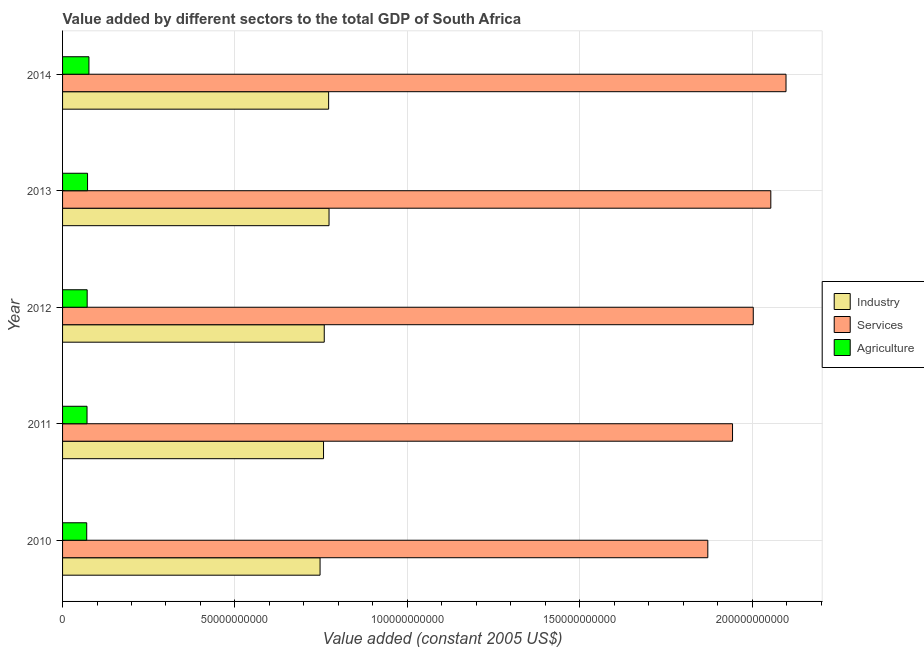How many different coloured bars are there?
Ensure brevity in your answer.  3. Are the number of bars per tick equal to the number of legend labels?
Ensure brevity in your answer.  Yes. Are the number of bars on each tick of the Y-axis equal?
Your answer should be compact. Yes. How many bars are there on the 5th tick from the top?
Your answer should be very brief. 3. How many bars are there on the 2nd tick from the bottom?
Make the answer very short. 3. In how many cases, is the number of bars for a given year not equal to the number of legend labels?
Offer a very short reply. 0. What is the value added by agricultural sector in 2013?
Provide a succinct answer. 7.25e+09. Across all years, what is the maximum value added by industrial sector?
Provide a succinct answer. 7.73e+1. Across all years, what is the minimum value added by agricultural sector?
Offer a very short reply. 7.00e+09. In which year was the value added by agricultural sector minimum?
Your response must be concise. 2010. What is the total value added by agricultural sector in the graph?
Your response must be concise. 3.61e+1. What is the difference between the value added by services in 2012 and that in 2014?
Ensure brevity in your answer.  -9.50e+09. What is the difference between the value added by industrial sector in 2010 and the value added by agricultural sector in 2013?
Your answer should be compact. 6.74e+1. What is the average value added by industrial sector per year?
Keep it short and to the point. 7.62e+1. In the year 2012, what is the difference between the value added by services and value added by agricultural sector?
Keep it short and to the point. 1.93e+11. In how many years, is the value added by industrial sector greater than 210000000000 US$?
Your response must be concise. 0. What is the ratio of the value added by agricultural sector in 2011 to that in 2012?
Offer a terse response. 0.99. Is the value added by industrial sector in 2011 less than that in 2013?
Give a very brief answer. Yes. Is the difference between the value added by agricultural sector in 2011 and 2013 greater than the difference between the value added by industrial sector in 2011 and 2013?
Offer a very short reply. Yes. What is the difference between the highest and the second highest value added by industrial sector?
Provide a succinct answer. 1.20e+08. What is the difference between the highest and the lowest value added by agricultural sector?
Offer a terse response. 6.46e+08. What does the 3rd bar from the top in 2011 represents?
Ensure brevity in your answer.  Industry. What does the 2nd bar from the bottom in 2014 represents?
Provide a short and direct response. Services. Is it the case that in every year, the sum of the value added by industrial sector and value added by services is greater than the value added by agricultural sector?
Keep it short and to the point. Yes. How many bars are there?
Your answer should be very brief. 15. Are all the bars in the graph horizontal?
Offer a terse response. Yes. How many years are there in the graph?
Provide a short and direct response. 5. Are the values on the major ticks of X-axis written in scientific E-notation?
Offer a very short reply. No. Does the graph contain any zero values?
Keep it short and to the point. No. Does the graph contain grids?
Provide a short and direct response. Yes. Where does the legend appear in the graph?
Provide a succinct answer. Center right. How many legend labels are there?
Make the answer very short. 3. What is the title of the graph?
Offer a very short reply. Value added by different sectors to the total GDP of South Africa. What is the label or title of the X-axis?
Give a very brief answer. Value added (constant 2005 US$). What is the Value added (constant 2005 US$) of Industry in 2010?
Your answer should be compact. 7.47e+1. What is the Value added (constant 2005 US$) in Services in 2010?
Your response must be concise. 1.87e+11. What is the Value added (constant 2005 US$) of Agriculture in 2010?
Offer a very short reply. 7.00e+09. What is the Value added (constant 2005 US$) in Industry in 2011?
Your response must be concise. 7.57e+1. What is the Value added (constant 2005 US$) in Services in 2011?
Your answer should be very brief. 1.94e+11. What is the Value added (constant 2005 US$) in Agriculture in 2011?
Your answer should be compact. 7.10e+09. What is the Value added (constant 2005 US$) of Industry in 2012?
Ensure brevity in your answer.  7.59e+1. What is the Value added (constant 2005 US$) of Services in 2012?
Make the answer very short. 2.00e+11. What is the Value added (constant 2005 US$) of Agriculture in 2012?
Your answer should be compact. 7.14e+09. What is the Value added (constant 2005 US$) of Industry in 2013?
Offer a very short reply. 7.73e+1. What is the Value added (constant 2005 US$) of Services in 2013?
Offer a very short reply. 2.05e+11. What is the Value added (constant 2005 US$) in Agriculture in 2013?
Make the answer very short. 7.25e+09. What is the Value added (constant 2005 US$) of Industry in 2014?
Offer a very short reply. 7.72e+1. What is the Value added (constant 2005 US$) of Services in 2014?
Give a very brief answer. 2.10e+11. What is the Value added (constant 2005 US$) in Agriculture in 2014?
Give a very brief answer. 7.65e+09. Across all years, what is the maximum Value added (constant 2005 US$) in Industry?
Offer a very short reply. 7.73e+1. Across all years, what is the maximum Value added (constant 2005 US$) of Services?
Your answer should be very brief. 2.10e+11. Across all years, what is the maximum Value added (constant 2005 US$) of Agriculture?
Offer a very short reply. 7.65e+09. Across all years, what is the minimum Value added (constant 2005 US$) of Industry?
Provide a succinct answer. 7.47e+1. Across all years, what is the minimum Value added (constant 2005 US$) in Services?
Offer a terse response. 1.87e+11. Across all years, what is the minimum Value added (constant 2005 US$) of Agriculture?
Give a very brief answer. 7.00e+09. What is the total Value added (constant 2005 US$) of Industry in the graph?
Ensure brevity in your answer.  3.81e+11. What is the total Value added (constant 2005 US$) in Services in the graph?
Make the answer very short. 9.97e+11. What is the total Value added (constant 2005 US$) in Agriculture in the graph?
Ensure brevity in your answer.  3.61e+1. What is the difference between the Value added (constant 2005 US$) of Industry in 2010 and that in 2011?
Offer a very short reply. -1.01e+09. What is the difference between the Value added (constant 2005 US$) of Services in 2010 and that in 2011?
Offer a terse response. -7.17e+09. What is the difference between the Value added (constant 2005 US$) of Agriculture in 2010 and that in 2011?
Give a very brief answer. -9.17e+07. What is the difference between the Value added (constant 2005 US$) of Industry in 2010 and that in 2012?
Your answer should be compact. -1.22e+09. What is the difference between the Value added (constant 2005 US$) of Services in 2010 and that in 2012?
Your response must be concise. -1.32e+1. What is the difference between the Value added (constant 2005 US$) in Agriculture in 2010 and that in 2012?
Keep it short and to the point. -1.34e+08. What is the difference between the Value added (constant 2005 US$) of Industry in 2010 and that in 2013?
Keep it short and to the point. -2.60e+09. What is the difference between the Value added (constant 2005 US$) of Services in 2010 and that in 2013?
Give a very brief answer. -1.83e+1. What is the difference between the Value added (constant 2005 US$) in Agriculture in 2010 and that in 2013?
Keep it short and to the point. -2.43e+08. What is the difference between the Value added (constant 2005 US$) in Industry in 2010 and that in 2014?
Provide a short and direct response. -2.48e+09. What is the difference between the Value added (constant 2005 US$) in Services in 2010 and that in 2014?
Offer a terse response. -2.27e+1. What is the difference between the Value added (constant 2005 US$) in Agriculture in 2010 and that in 2014?
Provide a short and direct response. -6.46e+08. What is the difference between the Value added (constant 2005 US$) in Industry in 2011 and that in 2012?
Give a very brief answer. -2.09e+08. What is the difference between the Value added (constant 2005 US$) of Services in 2011 and that in 2012?
Provide a short and direct response. -6.01e+09. What is the difference between the Value added (constant 2005 US$) in Agriculture in 2011 and that in 2012?
Offer a very short reply. -4.24e+07. What is the difference between the Value added (constant 2005 US$) of Industry in 2011 and that in 2013?
Provide a short and direct response. -1.60e+09. What is the difference between the Value added (constant 2005 US$) in Services in 2011 and that in 2013?
Provide a succinct answer. -1.11e+1. What is the difference between the Value added (constant 2005 US$) of Agriculture in 2011 and that in 2013?
Keep it short and to the point. -1.51e+08. What is the difference between the Value added (constant 2005 US$) of Industry in 2011 and that in 2014?
Keep it short and to the point. -1.48e+09. What is the difference between the Value added (constant 2005 US$) in Services in 2011 and that in 2014?
Offer a terse response. -1.55e+1. What is the difference between the Value added (constant 2005 US$) in Agriculture in 2011 and that in 2014?
Ensure brevity in your answer.  -5.55e+08. What is the difference between the Value added (constant 2005 US$) of Industry in 2012 and that in 2013?
Give a very brief answer. -1.39e+09. What is the difference between the Value added (constant 2005 US$) in Services in 2012 and that in 2013?
Provide a short and direct response. -5.09e+09. What is the difference between the Value added (constant 2005 US$) in Agriculture in 2012 and that in 2013?
Provide a short and direct response. -1.09e+08. What is the difference between the Value added (constant 2005 US$) in Industry in 2012 and that in 2014?
Make the answer very short. -1.27e+09. What is the difference between the Value added (constant 2005 US$) of Services in 2012 and that in 2014?
Provide a short and direct response. -9.50e+09. What is the difference between the Value added (constant 2005 US$) in Agriculture in 2012 and that in 2014?
Your answer should be very brief. -5.12e+08. What is the difference between the Value added (constant 2005 US$) of Industry in 2013 and that in 2014?
Keep it short and to the point. 1.20e+08. What is the difference between the Value added (constant 2005 US$) of Services in 2013 and that in 2014?
Provide a short and direct response. -4.41e+09. What is the difference between the Value added (constant 2005 US$) of Agriculture in 2013 and that in 2014?
Give a very brief answer. -4.03e+08. What is the difference between the Value added (constant 2005 US$) of Industry in 2010 and the Value added (constant 2005 US$) of Services in 2011?
Your answer should be compact. -1.20e+11. What is the difference between the Value added (constant 2005 US$) in Industry in 2010 and the Value added (constant 2005 US$) in Agriculture in 2011?
Your answer should be compact. 6.76e+1. What is the difference between the Value added (constant 2005 US$) in Services in 2010 and the Value added (constant 2005 US$) in Agriculture in 2011?
Give a very brief answer. 1.80e+11. What is the difference between the Value added (constant 2005 US$) in Industry in 2010 and the Value added (constant 2005 US$) in Services in 2012?
Make the answer very short. -1.26e+11. What is the difference between the Value added (constant 2005 US$) in Industry in 2010 and the Value added (constant 2005 US$) in Agriculture in 2012?
Make the answer very short. 6.76e+1. What is the difference between the Value added (constant 2005 US$) of Services in 2010 and the Value added (constant 2005 US$) of Agriculture in 2012?
Keep it short and to the point. 1.80e+11. What is the difference between the Value added (constant 2005 US$) in Industry in 2010 and the Value added (constant 2005 US$) in Services in 2013?
Keep it short and to the point. -1.31e+11. What is the difference between the Value added (constant 2005 US$) of Industry in 2010 and the Value added (constant 2005 US$) of Agriculture in 2013?
Provide a short and direct response. 6.74e+1. What is the difference between the Value added (constant 2005 US$) of Services in 2010 and the Value added (constant 2005 US$) of Agriculture in 2013?
Your answer should be very brief. 1.80e+11. What is the difference between the Value added (constant 2005 US$) in Industry in 2010 and the Value added (constant 2005 US$) in Services in 2014?
Offer a terse response. -1.35e+11. What is the difference between the Value added (constant 2005 US$) in Industry in 2010 and the Value added (constant 2005 US$) in Agriculture in 2014?
Your answer should be very brief. 6.70e+1. What is the difference between the Value added (constant 2005 US$) of Services in 2010 and the Value added (constant 2005 US$) of Agriculture in 2014?
Give a very brief answer. 1.80e+11. What is the difference between the Value added (constant 2005 US$) of Industry in 2011 and the Value added (constant 2005 US$) of Services in 2012?
Offer a terse response. -1.25e+11. What is the difference between the Value added (constant 2005 US$) of Industry in 2011 and the Value added (constant 2005 US$) of Agriculture in 2012?
Your answer should be compact. 6.86e+1. What is the difference between the Value added (constant 2005 US$) of Services in 2011 and the Value added (constant 2005 US$) of Agriculture in 2012?
Your response must be concise. 1.87e+11. What is the difference between the Value added (constant 2005 US$) of Industry in 2011 and the Value added (constant 2005 US$) of Services in 2013?
Provide a succinct answer. -1.30e+11. What is the difference between the Value added (constant 2005 US$) of Industry in 2011 and the Value added (constant 2005 US$) of Agriculture in 2013?
Ensure brevity in your answer.  6.84e+1. What is the difference between the Value added (constant 2005 US$) in Services in 2011 and the Value added (constant 2005 US$) in Agriculture in 2013?
Your response must be concise. 1.87e+11. What is the difference between the Value added (constant 2005 US$) of Industry in 2011 and the Value added (constant 2005 US$) of Services in 2014?
Your response must be concise. -1.34e+11. What is the difference between the Value added (constant 2005 US$) in Industry in 2011 and the Value added (constant 2005 US$) in Agriculture in 2014?
Offer a very short reply. 6.80e+1. What is the difference between the Value added (constant 2005 US$) of Services in 2011 and the Value added (constant 2005 US$) of Agriculture in 2014?
Your response must be concise. 1.87e+11. What is the difference between the Value added (constant 2005 US$) of Industry in 2012 and the Value added (constant 2005 US$) of Services in 2013?
Provide a short and direct response. -1.30e+11. What is the difference between the Value added (constant 2005 US$) in Industry in 2012 and the Value added (constant 2005 US$) in Agriculture in 2013?
Your answer should be very brief. 6.87e+1. What is the difference between the Value added (constant 2005 US$) of Services in 2012 and the Value added (constant 2005 US$) of Agriculture in 2013?
Make the answer very short. 1.93e+11. What is the difference between the Value added (constant 2005 US$) of Industry in 2012 and the Value added (constant 2005 US$) of Services in 2014?
Offer a very short reply. -1.34e+11. What is the difference between the Value added (constant 2005 US$) in Industry in 2012 and the Value added (constant 2005 US$) in Agriculture in 2014?
Your response must be concise. 6.83e+1. What is the difference between the Value added (constant 2005 US$) in Services in 2012 and the Value added (constant 2005 US$) in Agriculture in 2014?
Your answer should be compact. 1.93e+11. What is the difference between the Value added (constant 2005 US$) in Industry in 2013 and the Value added (constant 2005 US$) in Services in 2014?
Keep it short and to the point. -1.33e+11. What is the difference between the Value added (constant 2005 US$) in Industry in 2013 and the Value added (constant 2005 US$) in Agriculture in 2014?
Provide a short and direct response. 6.96e+1. What is the difference between the Value added (constant 2005 US$) in Services in 2013 and the Value added (constant 2005 US$) in Agriculture in 2014?
Make the answer very short. 1.98e+11. What is the average Value added (constant 2005 US$) in Industry per year?
Provide a succinct answer. 7.62e+1. What is the average Value added (constant 2005 US$) in Services per year?
Give a very brief answer. 1.99e+11. What is the average Value added (constant 2005 US$) in Agriculture per year?
Your answer should be compact. 7.23e+09. In the year 2010, what is the difference between the Value added (constant 2005 US$) in Industry and Value added (constant 2005 US$) in Services?
Your answer should be compact. -1.12e+11. In the year 2010, what is the difference between the Value added (constant 2005 US$) in Industry and Value added (constant 2005 US$) in Agriculture?
Keep it short and to the point. 6.77e+1. In the year 2010, what is the difference between the Value added (constant 2005 US$) of Services and Value added (constant 2005 US$) of Agriculture?
Give a very brief answer. 1.80e+11. In the year 2011, what is the difference between the Value added (constant 2005 US$) of Industry and Value added (constant 2005 US$) of Services?
Ensure brevity in your answer.  -1.19e+11. In the year 2011, what is the difference between the Value added (constant 2005 US$) of Industry and Value added (constant 2005 US$) of Agriculture?
Your answer should be very brief. 6.86e+1. In the year 2011, what is the difference between the Value added (constant 2005 US$) of Services and Value added (constant 2005 US$) of Agriculture?
Your response must be concise. 1.87e+11. In the year 2012, what is the difference between the Value added (constant 2005 US$) of Industry and Value added (constant 2005 US$) of Services?
Keep it short and to the point. -1.24e+11. In the year 2012, what is the difference between the Value added (constant 2005 US$) of Industry and Value added (constant 2005 US$) of Agriculture?
Provide a succinct answer. 6.88e+1. In the year 2012, what is the difference between the Value added (constant 2005 US$) in Services and Value added (constant 2005 US$) in Agriculture?
Offer a terse response. 1.93e+11. In the year 2013, what is the difference between the Value added (constant 2005 US$) in Industry and Value added (constant 2005 US$) in Services?
Your answer should be very brief. -1.28e+11. In the year 2013, what is the difference between the Value added (constant 2005 US$) of Industry and Value added (constant 2005 US$) of Agriculture?
Offer a very short reply. 7.00e+1. In the year 2013, what is the difference between the Value added (constant 2005 US$) in Services and Value added (constant 2005 US$) in Agriculture?
Your answer should be very brief. 1.98e+11. In the year 2014, what is the difference between the Value added (constant 2005 US$) of Industry and Value added (constant 2005 US$) of Services?
Ensure brevity in your answer.  -1.33e+11. In the year 2014, what is the difference between the Value added (constant 2005 US$) in Industry and Value added (constant 2005 US$) in Agriculture?
Your answer should be very brief. 6.95e+1. In the year 2014, what is the difference between the Value added (constant 2005 US$) in Services and Value added (constant 2005 US$) in Agriculture?
Make the answer very short. 2.02e+11. What is the ratio of the Value added (constant 2005 US$) in Industry in 2010 to that in 2011?
Make the answer very short. 0.99. What is the ratio of the Value added (constant 2005 US$) in Services in 2010 to that in 2011?
Make the answer very short. 0.96. What is the ratio of the Value added (constant 2005 US$) in Agriculture in 2010 to that in 2011?
Offer a terse response. 0.99. What is the ratio of the Value added (constant 2005 US$) in Services in 2010 to that in 2012?
Your answer should be very brief. 0.93. What is the ratio of the Value added (constant 2005 US$) of Agriculture in 2010 to that in 2012?
Ensure brevity in your answer.  0.98. What is the ratio of the Value added (constant 2005 US$) of Industry in 2010 to that in 2013?
Offer a very short reply. 0.97. What is the ratio of the Value added (constant 2005 US$) in Services in 2010 to that in 2013?
Your response must be concise. 0.91. What is the ratio of the Value added (constant 2005 US$) of Agriculture in 2010 to that in 2013?
Make the answer very short. 0.97. What is the ratio of the Value added (constant 2005 US$) in Industry in 2010 to that in 2014?
Keep it short and to the point. 0.97. What is the ratio of the Value added (constant 2005 US$) in Services in 2010 to that in 2014?
Make the answer very short. 0.89. What is the ratio of the Value added (constant 2005 US$) in Agriculture in 2010 to that in 2014?
Ensure brevity in your answer.  0.92. What is the ratio of the Value added (constant 2005 US$) in Services in 2011 to that in 2012?
Give a very brief answer. 0.97. What is the ratio of the Value added (constant 2005 US$) of Agriculture in 2011 to that in 2012?
Ensure brevity in your answer.  0.99. What is the ratio of the Value added (constant 2005 US$) of Industry in 2011 to that in 2013?
Make the answer very short. 0.98. What is the ratio of the Value added (constant 2005 US$) in Services in 2011 to that in 2013?
Offer a terse response. 0.95. What is the ratio of the Value added (constant 2005 US$) in Agriculture in 2011 to that in 2013?
Offer a terse response. 0.98. What is the ratio of the Value added (constant 2005 US$) in Industry in 2011 to that in 2014?
Keep it short and to the point. 0.98. What is the ratio of the Value added (constant 2005 US$) in Services in 2011 to that in 2014?
Provide a succinct answer. 0.93. What is the ratio of the Value added (constant 2005 US$) in Agriculture in 2011 to that in 2014?
Keep it short and to the point. 0.93. What is the ratio of the Value added (constant 2005 US$) in Services in 2012 to that in 2013?
Ensure brevity in your answer.  0.98. What is the ratio of the Value added (constant 2005 US$) of Industry in 2012 to that in 2014?
Give a very brief answer. 0.98. What is the ratio of the Value added (constant 2005 US$) in Services in 2012 to that in 2014?
Ensure brevity in your answer.  0.95. What is the ratio of the Value added (constant 2005 US$) in Agriculture in 2012 to that in 2014?
Make the answer very short. 0.93. What is the ratio of the Value added (constant 2005 US$) in Industry in 2013 to that in 2014?
Give a very brief answer. 1. What is the ratio of the Value added (constant 2005 US$) in Services in 2013 to that in 2014?
Ensure brevity in your answer.  0.98. What is the ratio of the Value added (constant 2005 US$) of Agriculture in 2013 to that in 2014?
Offer a very short reply. 0.95. What is the difference between the highest and the second highest Value added (constant 2005 US$) of Industry?
Make the answer very short. 1.20e+08. What is the difference between the highest and the second highest Value added (constant 2005 US$) in Services?
Provide a short and direct response. 4.41e+09. What is the difference between the highest and the second highest Value added (constant 2005 US$) of Agriculture?
Your answer should be compact. 4.03e+08. What is the difference between the highest and the lowest Value added (constant 2005 US$) of Industry?
Provide a short and direct response. 2.60e+09. What is the difference between the highest and the lowest Value added (constant 2005 US$) of Services?
Provide a short and direct response. 2.27e+1. What is the difference between the highest and the lowest Value added (constant 2005 US$) of Agriculture?
Your answer should be compact. 6.46e+08. 